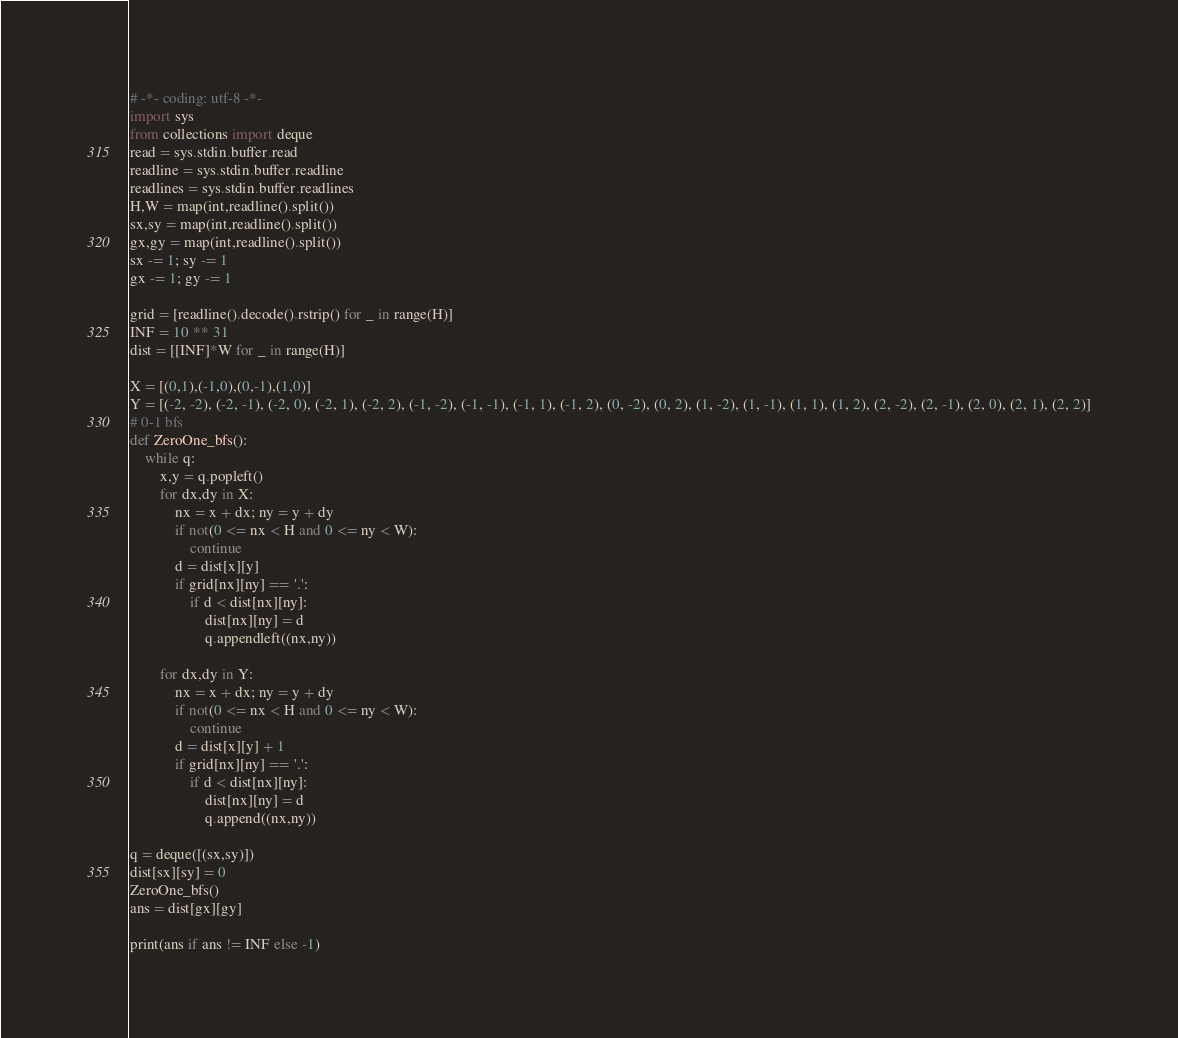<code> <loc_0><loc_0><loc_500><loc_500><_Python_># -*- coding: utf-8 -*-
import sys 
from collections import deque
read = sys.stdin.buffer.read
readline = sys.stdin.buffer.readline
readlines = sys.stdin.buffer.readlines
H,W = map(int,readline().split())
sx,sy = map(int,readline().split())
gx,gy = map(int,readline().split())
sx -= 1; sy -= 1
gx -= 1; gy -= 1

grid = [readline().decode().rstrip() for _ in range(H)]
INF = 10 ** 31
dist = [[INF]*W for _ in range(H)]

X = [(0,1),(-1,0),(0,-1),(1,0)]
Y = [(-2, -2), (-2, -1), (-2, 0), (-2, 1), (-2, 2), (-1, -2), (-1, -1), (-1, 1), (-1, 2), (0, -2), (0, 2), (1, -2), (1, -1), (1, 1), (1, 2), (2, -2), (2, -1), (2, 0), (2, 1), (2, 2)]
# 0-1 bfs
def ZeroOne_bfs():
    while q:
        x,y = q.popleft()
        for dx,dy in X:
            nx = x + dx; ny = y + dy
            if not(0 <= nx < H and 0 <= ny < W):
                continue
            d = dist[x][y]
            if grid[nx][ny] == '.':
                if d < dist[nx][ny]:
                    dist[nx][ny] = d
                    q.appendleft((nx,ny))
                    
        for dx,dy in Y:
            nx = x + dx; ny = y + dy
            if not(0 <= nx < H and 0 <= ny < W):
                continue
            d = dist[x][y] + 1
            if grid[nx][ny] == '.':
                if d < dist[nx][ny]:
                    dist[nx][ny] = d 
                    q.append((nx,ny))

q = deque([(sx,sy)])
dist[sx][sy] = 0
ZeroOne_bfs()
ans = dist[gx][gy]

print(ans if ans != INF else -1)</code> 